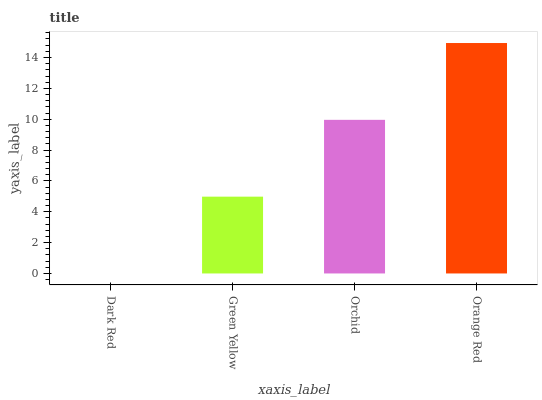Is Dark Red the minimum?
Answer yes or no. Yes. Is Orange Red the maximum?
Answer yes or no. Yes. Is Green Yellow the minimum?
Answer yes or no. No. Is Green Yellow the maximum?
Answer yes or no. No. Is Green Yellow greater than Dark Red?
Answer yes or no. Yes. Is Dark Red less than Green Yellow?
Answer yes or no. Yes. Is Dark Red greater than Green Yellow?
Answer yes or no. No. Is Green Yellow less than Dark Red?
Answer yes or no. No. Is Orchid the high median?
Answer yes or no. Yes. Is Green Yellow the low median?
Answer yes or no. Yes. Is Dark Red the high median?
Answer yes or no. No. Is Dark Red the low median?
Answer yes or no. No. 